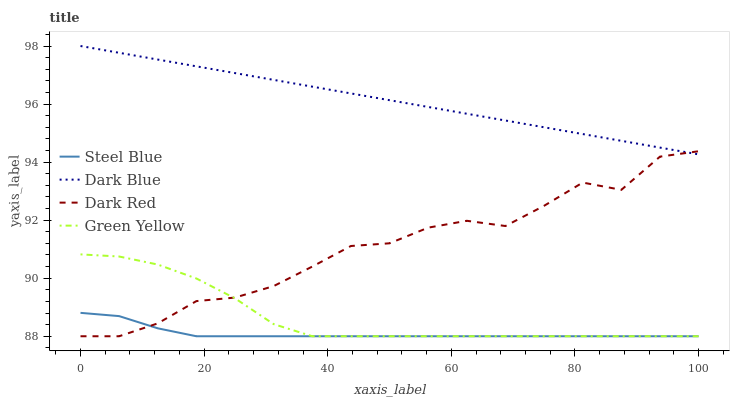Does Steel Blue have the minimum area under the curve?
Answer yes or no. Yes. Does Dark Blue have the maximum area under the curve?
Answer yes or no. Yes. Does Green Yellow have the minimum area under the curve?
Answer yes or no. No. Does Green Yellow have the maximum area under the curve?
Answer yes or no. No. Is Dark Blue the smoothest?
Answer yes or no. Yes. Is Dark Red the roughest?
Answer yes or no. Yes. Is Green Yellow the smoothest?
Answer yes or no. No. Is Green Yellow the roughest?
Answer yes or no. No. Does Green Yellow have the lowest value?
Answer yes or no. Yes. Does Dark Blue have the highest value?
Answer yes or no. Yes. Does Green Yellow have the highest value?
Answer yes or no. No. Is Steel Blue less than Dark Blue?
Answer yes or no. Yes. Is Dark Blue greater than Steel Blue?
Answer yes or no. Yes. Does Green Yellow intersect Dark Red?
Answer yes or no. Yes. Is Green Yellow less than Dark Red?
Answer yes or no. No. Is Green Yellow greater than Dark Red?
Answer yes or no. No. Does Steel Blue intersect Dark Blue?
Answer yes or no. No. 